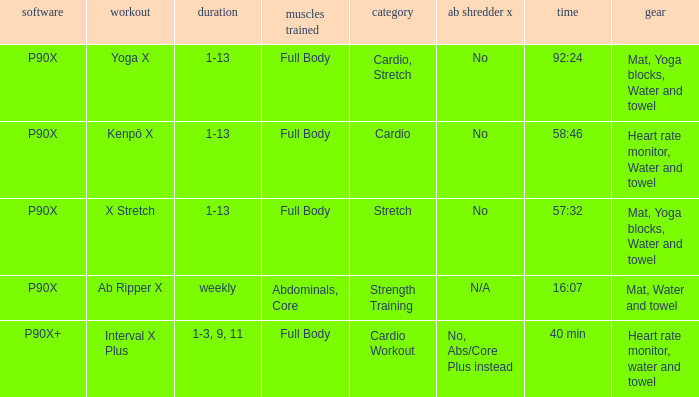What is the ab ripper x when exercise is x stretch? No. 